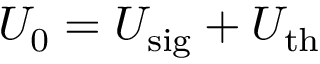Convert formula to latex. <formula><loc_0><loc_0><loc_500><loc_500>U _ { 0 } = U _ { s i g } + U _ { t h }</formula> 